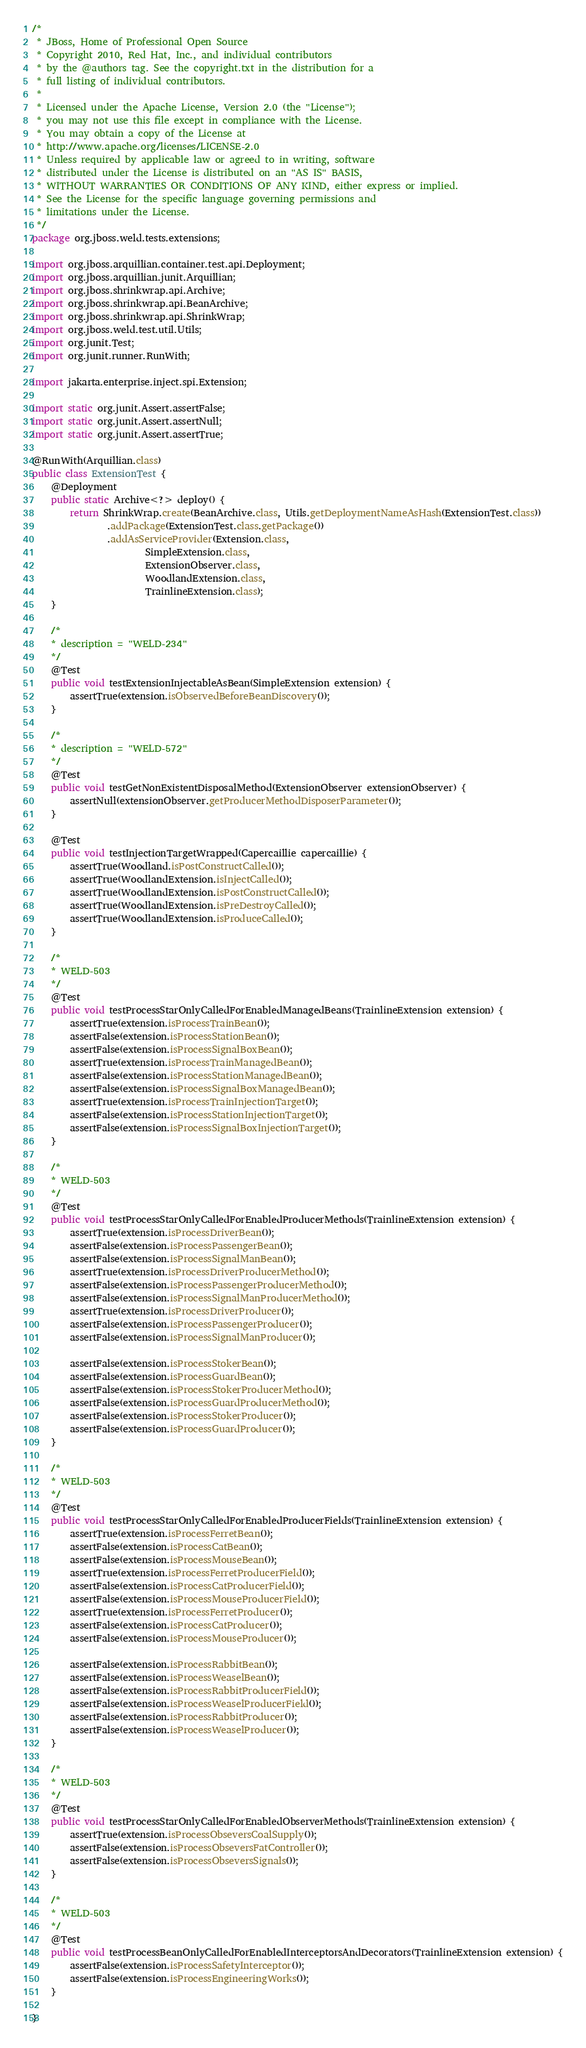<code> <loc_0><loc_0><loc_500><loc_500><_Java_>/*
 * JBoss, Home of Professional Open Source
 * Copyright 2010, Red Hat, Inc., and individual contributors
 * by the @authors tag. See the copyright.txt in the distribution for a
 * full listing of individual contributors.
 *
 * Licensed under the Apache License, Version 2.0 (the "License");
 * you may not use this file except in compliance with the License.
 * You may obtain a copy of the License at
 * http://www.apache.org/licenses/LICENSE-2.0
 * Unless required by applicable law or agreed to in writing, software
 * distributed under the License is distributed on an "AS IS" BASIS,
 * WITHOUT WARRANTIES OR CONDITIONS OF ANY KIND, either express or implied.
 * See the License for the specific language governing permissions and
 * limitations under the License.
 */
package org.jboss.weld.tests.extensions;

import org.jboss.arquillian.container.test.api.Deployment;
import org.jboss.arquillian.junit.Arquillian;
import org.jboss.shrinkwrap.api.Archive;
import org.jboss.shrinkwrap.api.BeanArchive;
import org.jboss.shrinkwrap.api.ShrinkWrap;
import org.jboss.weld.test.util.Utils;
import org.junit.Test;
import org.junit.runner.RunWith;

import jakarta.enterprise.inject.spi.Extension;

import static org.junit.Assert.assertFalse;
import static org.junit.Assert.assertNull;
import static org.junit.Assert.assertTrue;

@RunWith(Arquillian.class)
public class ExtensionTest {
    @Deployment
    public static Archive<?> deploy() {
        return ShrinkWrap.create(BeanArchive.class, Utils.getDeploymentNameAsHash(ExtensionTest.class))
                .addPackage(ExtensionTest.class.getPackage())
                .addAsServiceProvider(Extension.class,
                        SimpleExtension.class,
                        ExtensionObserver.class,
                        WoodlandExtension.class,
                        TrainlineExtension.class);
    }

    /*
    * description = "WELD-234"
    */
    @Test
    public void testExtensionInjectableAsBean(SimpleExtension extension) {
        assertTrue(extension.isObservedBeforeBeanDiscovery());
    }

    /*
    * description = "WELD-572"
    */
    @Test
    public void testGetNonExistentDisposalMethod(ExtensionObserver extensionObserver) {
        assertNull(extensionObserver.getProducerMethodDisposerParameter());
    }

    @Test
    public void testInjectionTargetWrapped(Capercaillie capercaillie) {
        assertTrue(Woodland.isPostConstructCalled());
        assertTrue(WoodlandExtension.isInjectCalled());
        assertTrue(WoodlandExtension.isPostConstructCalled());
        assertTrue(WoodlandExtension.isPreDestroyCalled());
        assertTrue(WoodlandExtension.isProduceCalled());
    }

    /*
    * WELD-503
    */
    @Test
    public void testProcessStarOnlyCalledForEnabledManagedBeans(TrainlineExtension extension) {
        assertTrue(extension.isProcessTrainBean());
        assertFalse(extension.isProcessStationBean());
        assertFalse(extension.isProcessSignalBoxBean());
        assertTrue(extension.isProcessTrainManagedBean());
        assertFalse(extension.isProcessStationManagedBean());
        assertFalse(extension.isProcessSignalBoxManagedBean());
        assertTrue(extension.isProcessTrainInjectionTarget());
        assertFalse(extension.isProcessStationInjectionTarget());
        assertFalse(extension.isProcessSignalBoxInjectionTarget());
    }

    /*
    * WELD-503
    */
    @Test
    public void testProcessStarOnlyCalledForEnabledProducerMethods(TrainlineExtension extension) {
        assertTrue(extension.isProcessDriverBean());
        assertFalse(extension.isProcessPassengerBean());
        assertFalse(extension.isProcessSignalManBean());
        assertTrue(extension.isProcessDriverProducerMethod());
        assertFalse(extension.isProcessPassengerProducerMethod());
        assertFalse(extension.isProcessSignalManProducerMethod());
        assertTrue(extension.isProcessDriverProducer());
        assertFalse(extension.isProcessPassengerProducer());
        assertFalse(extension.isProcessSignalManProducer());

        assertFalse(extension.isProcessStokerBean());
        assertFalse(extension.isProcessGuardBean());
        assertFalse(extension.isProcessStokerProducerMethod());
        assertFalse(extension.isProcessGuardProducerMethod());
        assertFalse(extension.isProcessStokerProducer());
        assertFalse(extension.isProcessGuardProducer());
    }

    /*
    * WELD-503
    */
    @Test
    public void testProcessStarOnlyCalledForEnabledProducerFields(TrainlineExtension extension) {
        assertTrue(extension.isProcessFerretBean());
        assertFalse(extension.isProcessCatBean());
        assertFalse(extension.isProcessMouseBean());
        assertTrue(extension.isProcessFerretProducerField());
        assertFalse(extension.isProcessCatProducerField());
        assertFalse(extension.isProcessMouseProducerField());
        assertTrue(extension.isProcessFerretProducer());
        assertFalse(extension.isProcessCatProducer());
        assertFalse(extension.isProcessMouseProducer());

        assertFalse(extension.isProcessRabbitBean());
        assertFalse(extension.isProcessWeaselBean());
        assertFalse(extension.isProcessRabbitProducerField());
        assertFalse(extension.isProcessWeaselProducerField());
        assertFalse(extension.isProcessRabbitProducer());
        assertFalse(extension.isProcessWeaselProducer());
    }

    /*
    * WELD-503
    */
    @Test
    public void testProcessStarOnlyCalledForEnabledObserverMethods(TrainlineExtension extension) {
        assertTrue(extension.isProcessObseversCoalSupply());
        assertFalse(extension.isProcessObseversFatController());
        assertFalse(extension.isProcessObseversSignals());
    }

    /*
    * WELD-503
    */
    @Test
    public void testProcessBeanOnlyCalledForEnabledInterceptorsAndDecorators(TrainlineExtension extension) {
        assertFalse(extension.isProcessSafetyInterceptor());
        assertFalse(extension.isProcessEngineeringWorks());
    }

}
</code> 